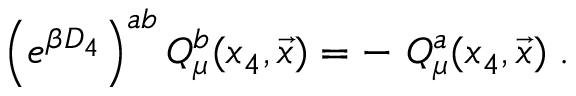<formula> <loc_0><loc_0><loc_500><loc_500>\left ( e ^ { \beta D _ { 4 } } \right ) ^ { a b } Q _ { \mu } ^ { b } ( x _ { 4 } , { \vec { x } } ) = - \ Q _ { \mu } ^ { a } ( x _ { 4 } , { \vec { x } } ) \, .</formula> 